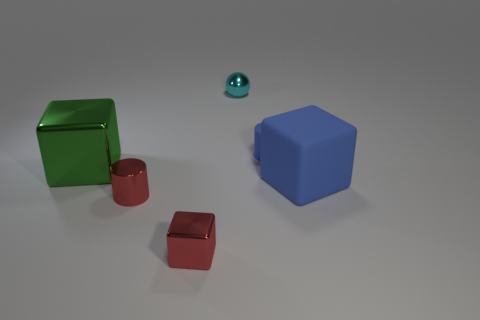Subtract all large blocks. How many blocks are left? 1 Subtract all red cubes. How many cubes are left? 2 Add 2 large green metal cubes. How many objects exist? 8 Subtract 1 spheres. How many spheres are left? 0 Subtract all cylinders. How many objects are left? 4 Subtract all large blue shiny cylinders. Subtract all large cubes. How many objects are left? 4 Add 6 metallic objects. How many metallic objects are left? 10 Add 6 cyan matte blocks. How many cyan matte blocks exist? 6 Subtract 0 yellow blocks. How many objects are left? 6 Subtract all blue cubes. Subtract all yellow cylinders. How many cubes are left? 2 